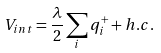<formula> <loc_0><loc_0><loc_500><loc_500>V _ { i n t } = \frac { \lambda } { 2 } \sum _ { i } q ^ { + } _ { i } + h . c .</formula> 